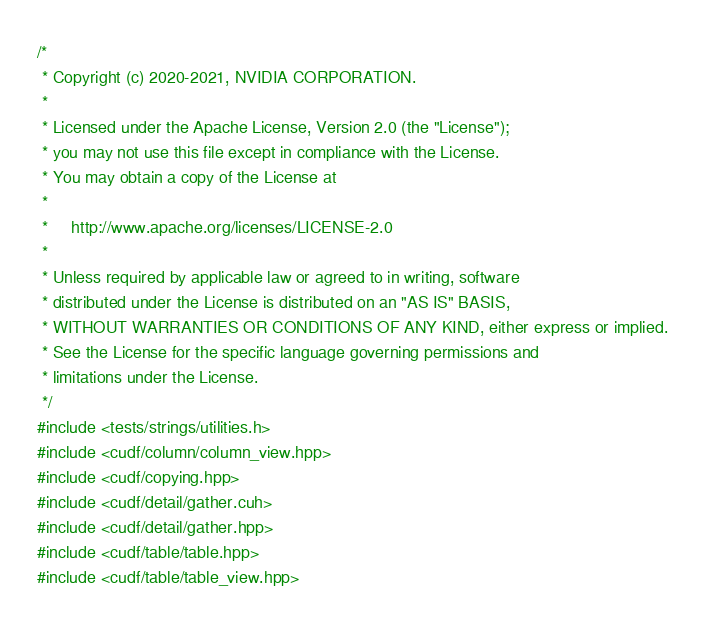<code> <loc_0><loc_0><loc_500><loc_500><_Cuda_>/*
 * Copyright (c) 2020-2021, NVIDIA CORPORATION.
 *
 * Licensed under the Apache License, Version 2.0 (the "License");
 * you may not use this file except in compliance with the License.
 * You may obtain a copy of the License at
 *
 *     http://www.apache.org/licenses/LICENSE-2.0
 *
 * Unless required by applicable law or agreed to in writing, software
 * distributed under the License is distributed on an "AS IS" BASIS,
 * WITHOUT WARRANTIES OR CONDITIONS OF ANY KIND, either express or implied.
 * See the License for the specific language governing permissions and
 * limitations under the License.
 */
#include <tests/strings/utilities.h>
#include <cudf/column/column_view.hpp>
#include <cudf/copying.hpp>
#include <cudf/detail/gather.cuh>
#include <cudf/detail/gather.hpp>
#include <cudf/table/table.hpp>
#include <cudf/table/table_view.hpp></code> 